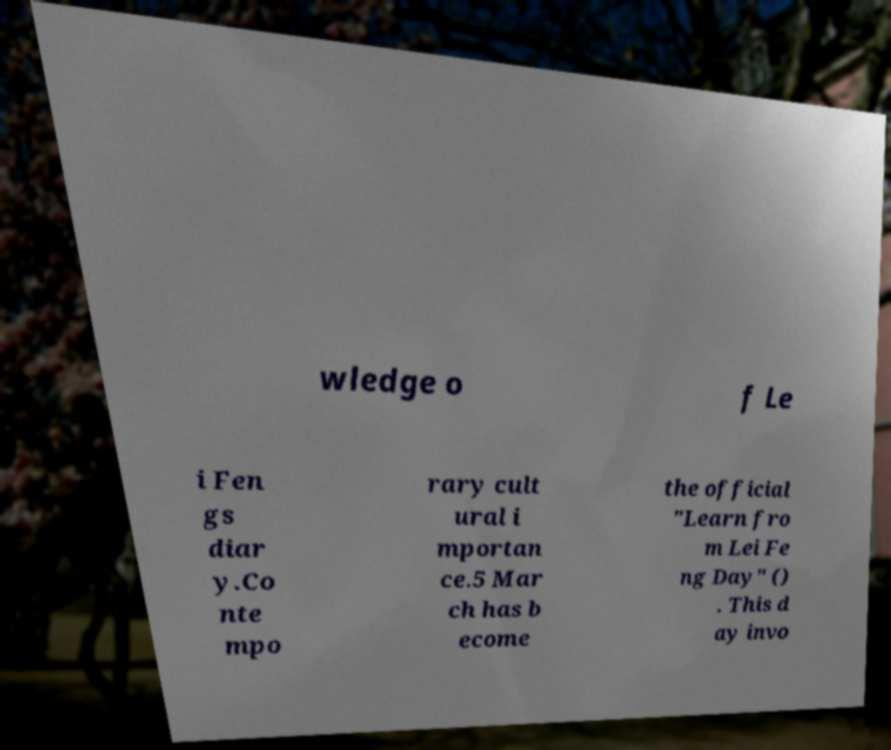Please identify and transcribe the text found in this image. wledge o f Le i Fen gs diar y.Co nte mpo rary cult ural i mportan ce.5 Mar ch has b ecome the official "Learn fro m Lei Fe ng Day" () . This d ay invo 